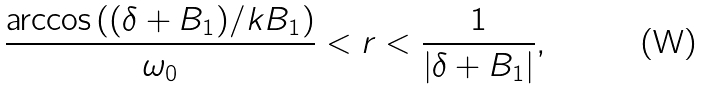Convert formula to latex. <formula><loc_0><loc_0><loc_500><loc_500>\frac { \arccos { ( ( \delta + B _ { 1 } ) / k B _ { 1 } ) } } { \omega _ { 0 } } < r < \frac { 1 } { | \delta + B _ { 1 } | } ,</formula> 